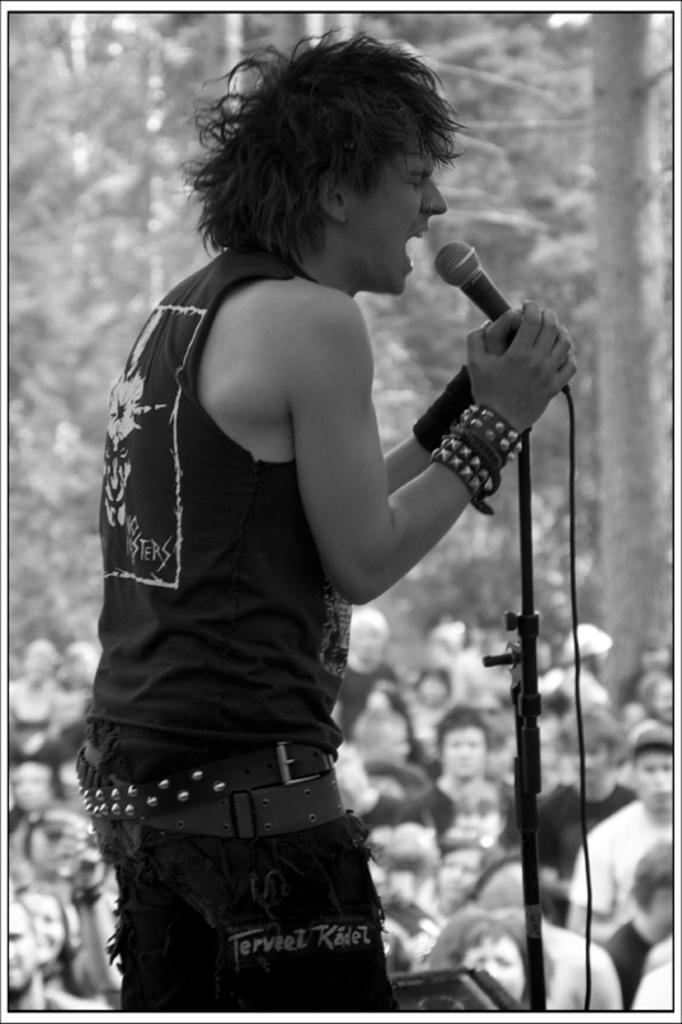Who is the main subject in the image? There is a man in the image. What is the man doing in the image? The man is standing and holding a mic. Can you describe the background of the image? There are people in the background of the image. What type of dinosaurs can be seen in the image? There are no dinosaurs present in the image. How does the man's memory affect the performance in the image? The image does not provide any information about the man's memory, so it cannot be determined how it affects the performance. 